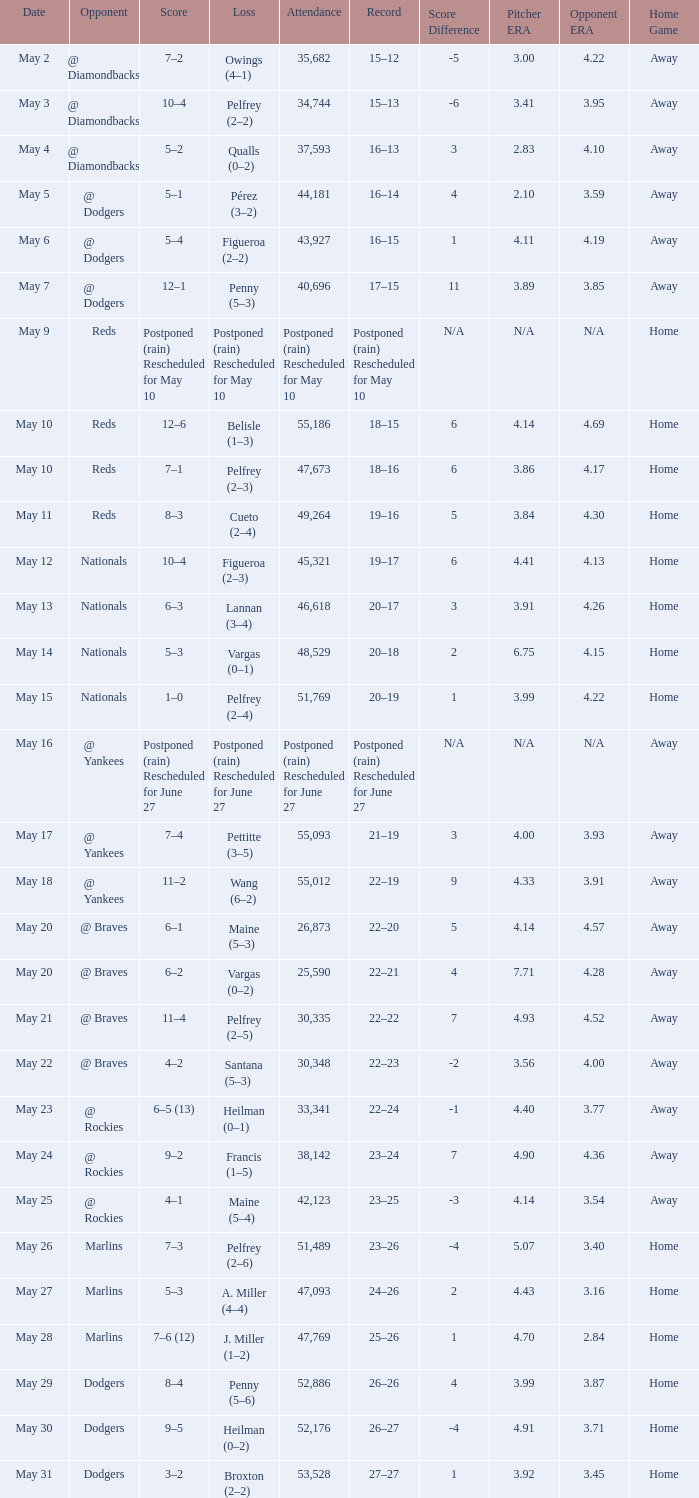Attendance of 30,335 had what record? 22–22. 